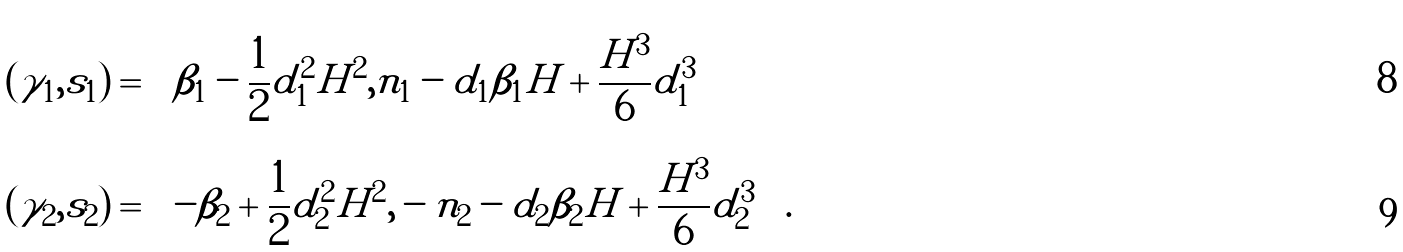Convert formula to latex. <formula><loc_0><loc_0><loc_500><loc_500>( \gamma _ { 1 } , s _ { 1 } ) & = \left ( \beta _ { 1 } - \frac { 1 } { 2 } d _ { 1 } ^ { 2 } H ^ { 2 } , n _ { 1 } - d _ { 1 } \beta _ { 1 } H + \frac { H ^ { 3 } } { 6 } d _ { 1 } ^ { 3 } \right ) \\ ( \gamma _ { 2 } , s _ { 2 } ) & = \left ( - \beta _ { 2 } + \frac { 1 } { 2 } d _ { 2 } ^ { 2 } H ^ { 2 } , - n _ { 2 } - d _ { 2 } \beta _ { 2 } H + \frac { H ^ { 3 } } { 6 } d _ { 2 } ^ { 3 } \right ) .</formula> 